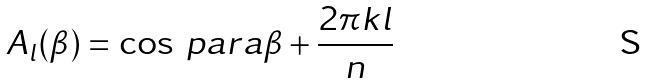<formula> <loc_0><loc_0><loc_500><loc_500>A _ { l } ( \beta ) = \cos \ p a r a { \beta + \frac { 2 \pi k l } { n } }</formula> 